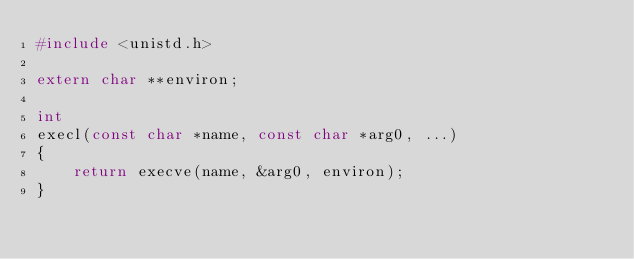<code> <loc_0><loc_0><loc_500><loc_500><_C_>#include <unistd.h>

extern char **environ;

int
execl(const char *name, const char *arg0, ...)
{
	return execve(name, &arg0, environ);
}
</code> 